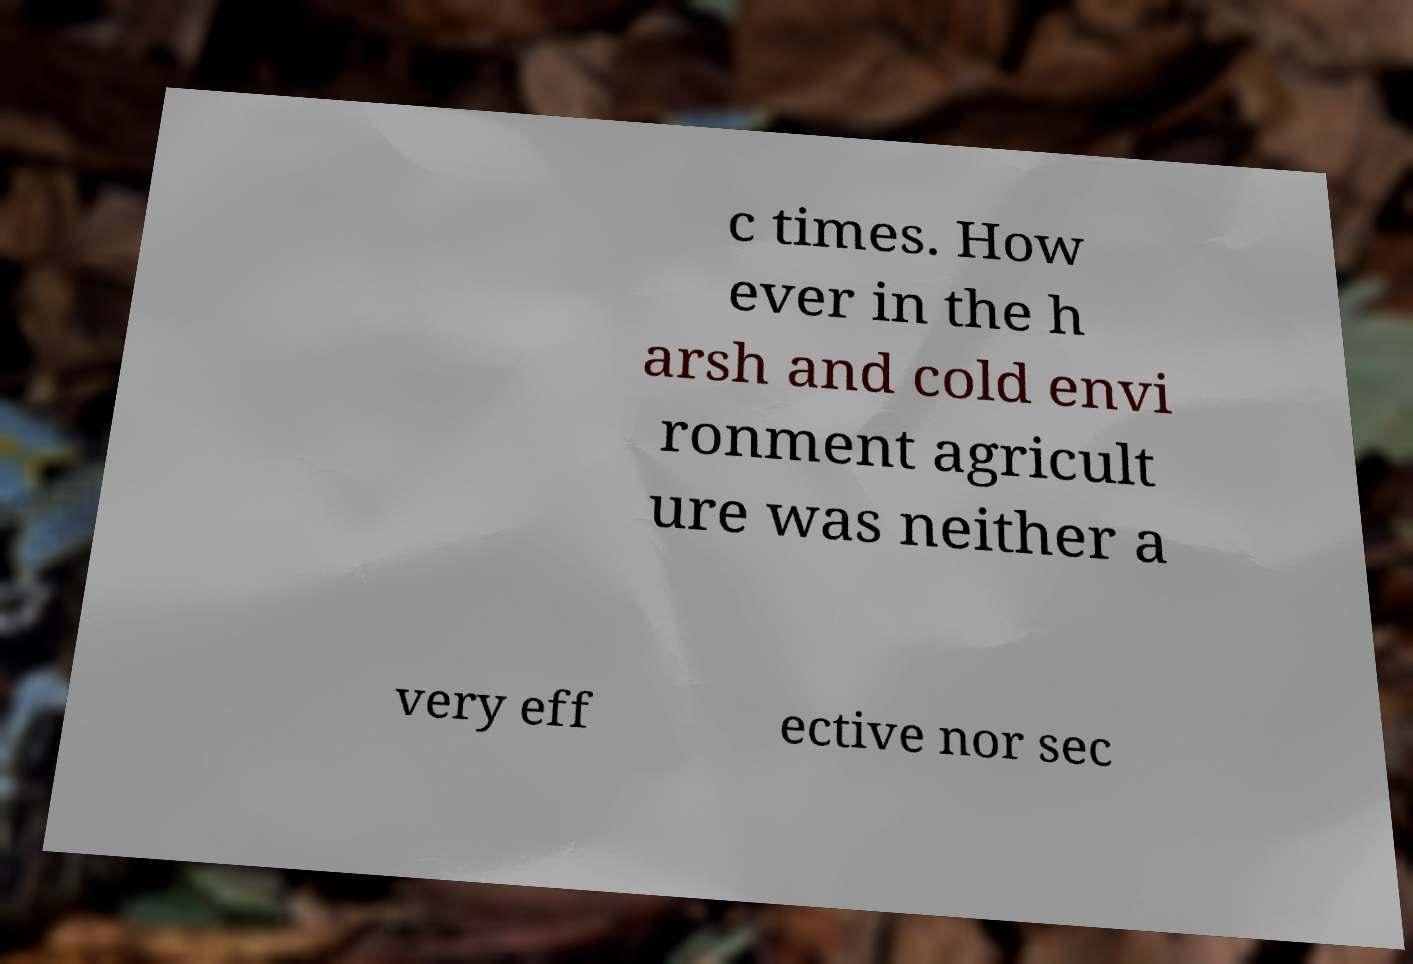Could you extract and type out the text from this image? c times. How ever in the h arsh and cold envi ronment agricult ure was neither a very eff ective nor sec 